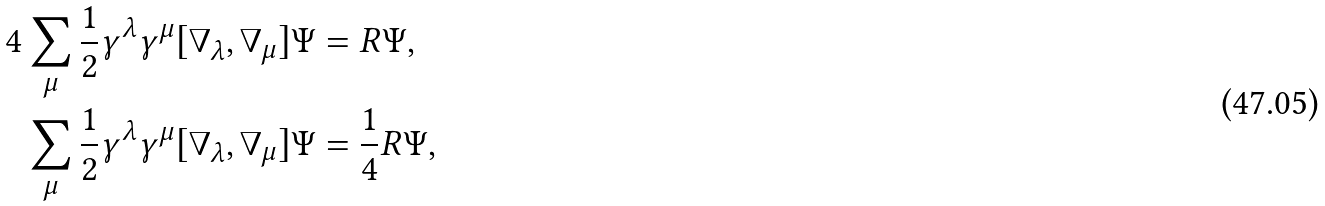<formula> <loc_0><loc_0><loc_500><loc_500>4 & \sum _ { \mu } \frac { 1 } { 2 } \gamma ^ { \lambda } \gamma ^ { \mu } [ \nabla _ { \lambda } , \nabla _ { \mu } ] \Psi = R \Psi , \\ & \sum _ { \mu } \frac { 1 } { 2 } \gamma ^ { \lambda } \gamma ^ { \mu } [ \nabla _ { \lambda } , \nabla _ { \mu } ] \Psi = \frac { 1 } { 4 } R \Psi ,</formula> 